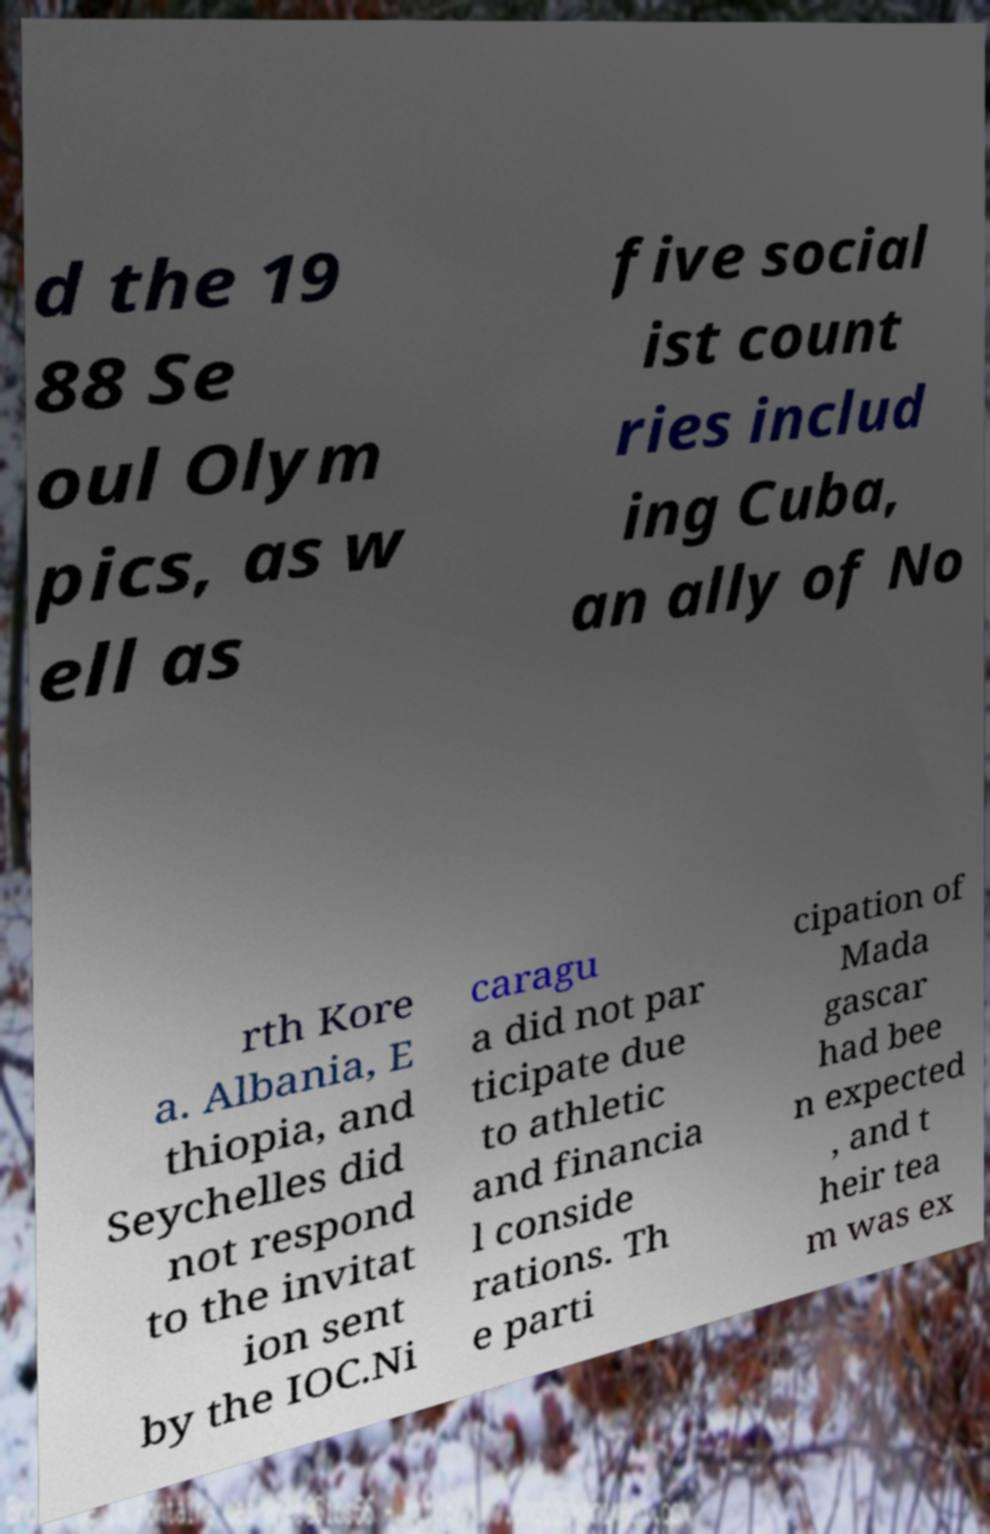What messages or text are displayed in this image? I need them in a readable, typed format. d the 19 88 Se oul Olym pics, as w ell as five social ist count ries includ ing Cuba, an ally of No rth Kore a. Albania, E thiopia, and Seychelles did not respond to the invitat ion sent by the IOC.Ni caragu a did not par ticipate due to athletic and financia l conside rations. Th e parti cipation of Mada gascar had bee n expected , and t heir tea m was ex 